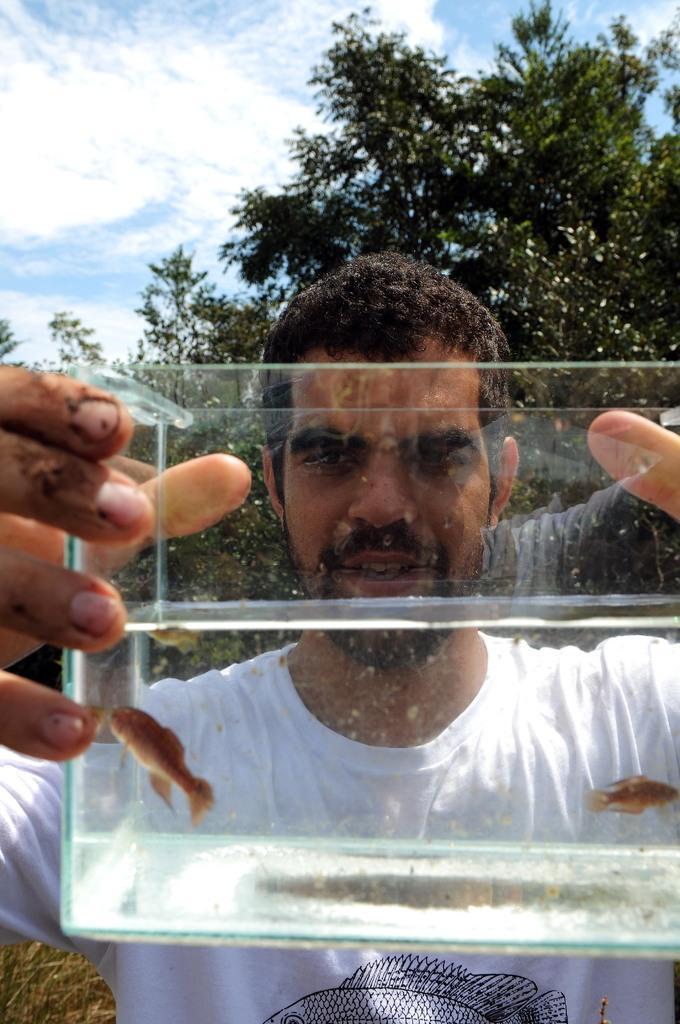Could you give a brief overview of what you see in this image? As we can see in the image there is a man wearing white color t shirt. There are trees, sky and clouds. 